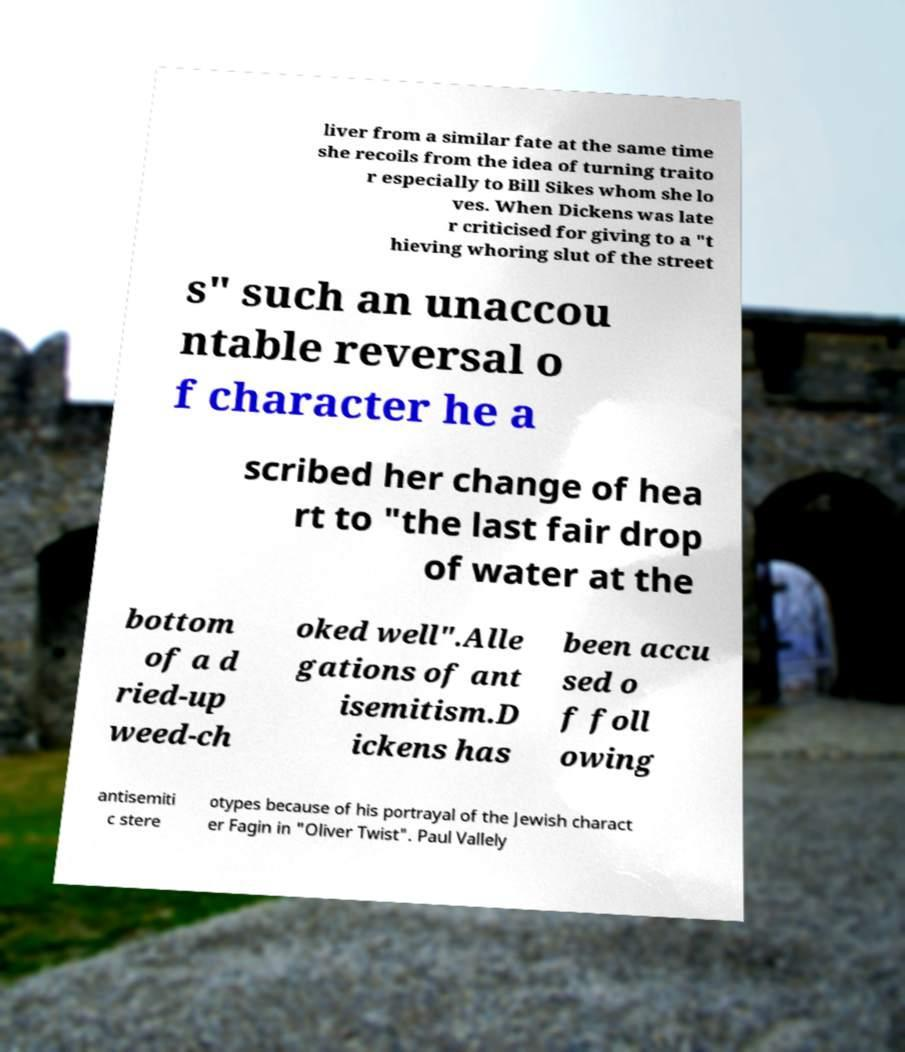Could you extract and type out the text from this image? liver from a similar fate at the same time she recoils from the idea of turning traito r especially to Bill Sikes whom she lo ves. When Dickens was late r criticised for giving to a "t hieving whoring slut of the street s" such an unaccou ntable reversal o f character he a scribed her change of hea rt to "the last fair drop of water at the bottom of a d ried-up weed-ch oked well".Alle gations of ant isemitism.D ickens has been accu sed o f foll owing antisemiti c stere otypes because of his portrayal of the Jewish charact er Fagin in "Oliver Twist". Paul Vallely 